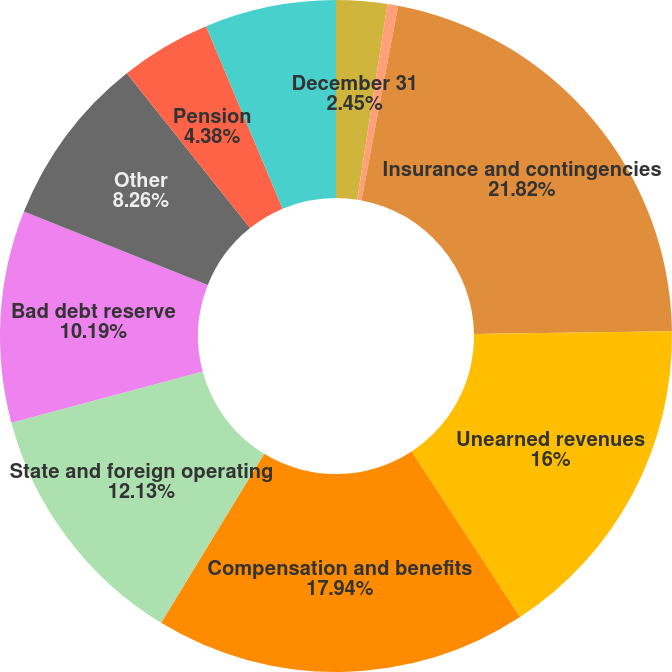<chart> <loc_0><loc_0><loc_500><loc_500><pie_chart><fcel>December 31<fcel>Termite accrual<fcel>Insurance and contingencies<fcel>Unearned revenues<fcel>Compensation and benefits<fcel>State and foreign operating<fcel>Bad debt reserve<fcel>Other<fcel>Pension<fcel>Valuation allowance<nl><fcel>2.45%<fcel>0.51%<fcel>21.81%<fcel>16.0%<fcel>17.94%<fcel>12.13%<fcel>10.19%<fcel>8.26%<fcel>4.38%<fcel>6.32%<nl></chart> 